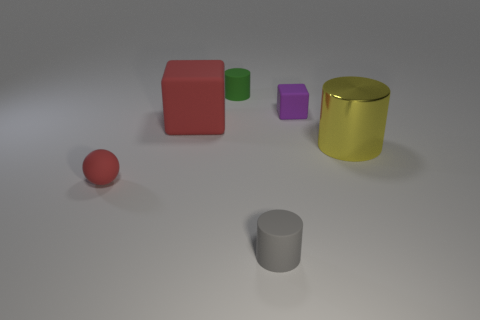There is a tiny matte cylinder behind the rubber block right of the small object behind the purple cube; what is its color?
Your response must be concise. Green. There is a green rubber object that is the same size as the gray matte cylinder; what is its shape?
Offer a terse response. Cylinder. Is the number of small red rubber spheres greater than the number of purple matte cylinders?
Offer a very short reply. Yes. There is a red object right of the tiny red ball; are there any blocks that are behind it?
Keep it short and to the point. Yes. What is the color of the other rubber object that is the same shape as the purple object?
Make the answer very short. Red. Is there any other thing that is the same shape as the small red rubber thing?
Offer a terse response. No. What is the color of the other cylinder that is made of the same material as the green cylinder?
Your answer should be very brief. Gray. Is there a small cylinder that is on the right side of the small rubber cylinder that is behind the small cylinder that is in front of the small purple rubber block?
Offer a terse response. Yes. Are there fewer red rubber things that are in front of the small gray rubber cylinder than small rubber spheres that are to the left of the shiny thing?
Provide a succinct answer. Yes. What number of things have the same material as the small block?
Offer a very short reply. 4. 